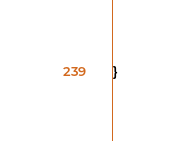Convert code to text. <code><loc_0><loc_0><loc_500><loc_500><_Kotlin_>}
</code> 